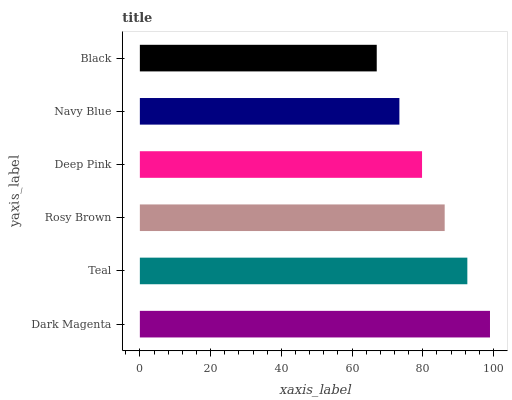Is Black the minimum?
Answer yes or no. Yes. Is Dark Magenta the maximum?
Answer yes or no. Yes. Is Teal the minimum?
Answer yes or no. No. Is Teal the maximum?
Answer yes or no. No. Is Dark Magenta greater than Teal?
Answer yes or no. Yes. Is Teal less than Dark Magenta?
Answer yes or no. Yes. Is Teal greater than Dark Magenta?
Answer yes or no. No. Is Dark Magenta less than Teal?
Answer yes or no. No. Is Rosy Brown the high median?
Answer yes or no. Yes. Is Deep Pink the low median?
Answer yes or no. Yes. Is Teal the high median?
Answer yes or no. No. Is Black the low median?
Answer yes or no. No. 